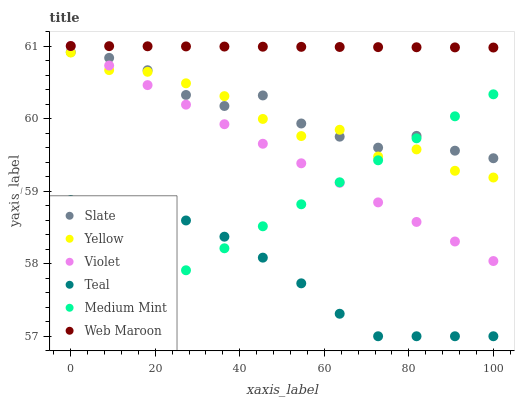Does Teal have the minimum area under the curve?
Answer yes or no. Yes. Does Web Maroon have the maximum area under the curve?
Answer yes or no. Yes. Does Slate have the minimum area under the curve?
Answer yes or no. No. Does Slate have the maximum area under the curve?
Answer yes or no. No. Is Web Maroon the smoothest?
Answer yes or no. Yes. Is Yellow the roughest?
Answer yes or no. Yes. Is Slate the smoothest?
Answer yes or no. No. Is Slate the roughest?
Answer yes or no. No. Does Medium Mint have the lowest value?
Answer yes or no. Yes. Does Slate have the lowest value?
Answer yes or no. No. Does Violet have the highest value?
Answer yes or no. Yes. Does Slate have the highest value?
Answer yes or no. No. Is Teal less than Violet?
Answer yes or no. Yes. Is Web Maroon greater than Medium Mint?
Answer yes or no. Yes. Does Slate intersect Violet?
Answer yes or no. Yes. Is Slate less than Violet?
Answer yes or no. No. Is Slate greater than Violet?
Answer yes or no. No. Does Teal intersect Violet?
Answer yes or no. No. 